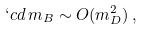<formula> <loc_0><loc_0><loc_500><loc_500>\lq c d \, m _ { B } \sim O ( m _ { D } ^ { 2 } ) \, ,</formula> 